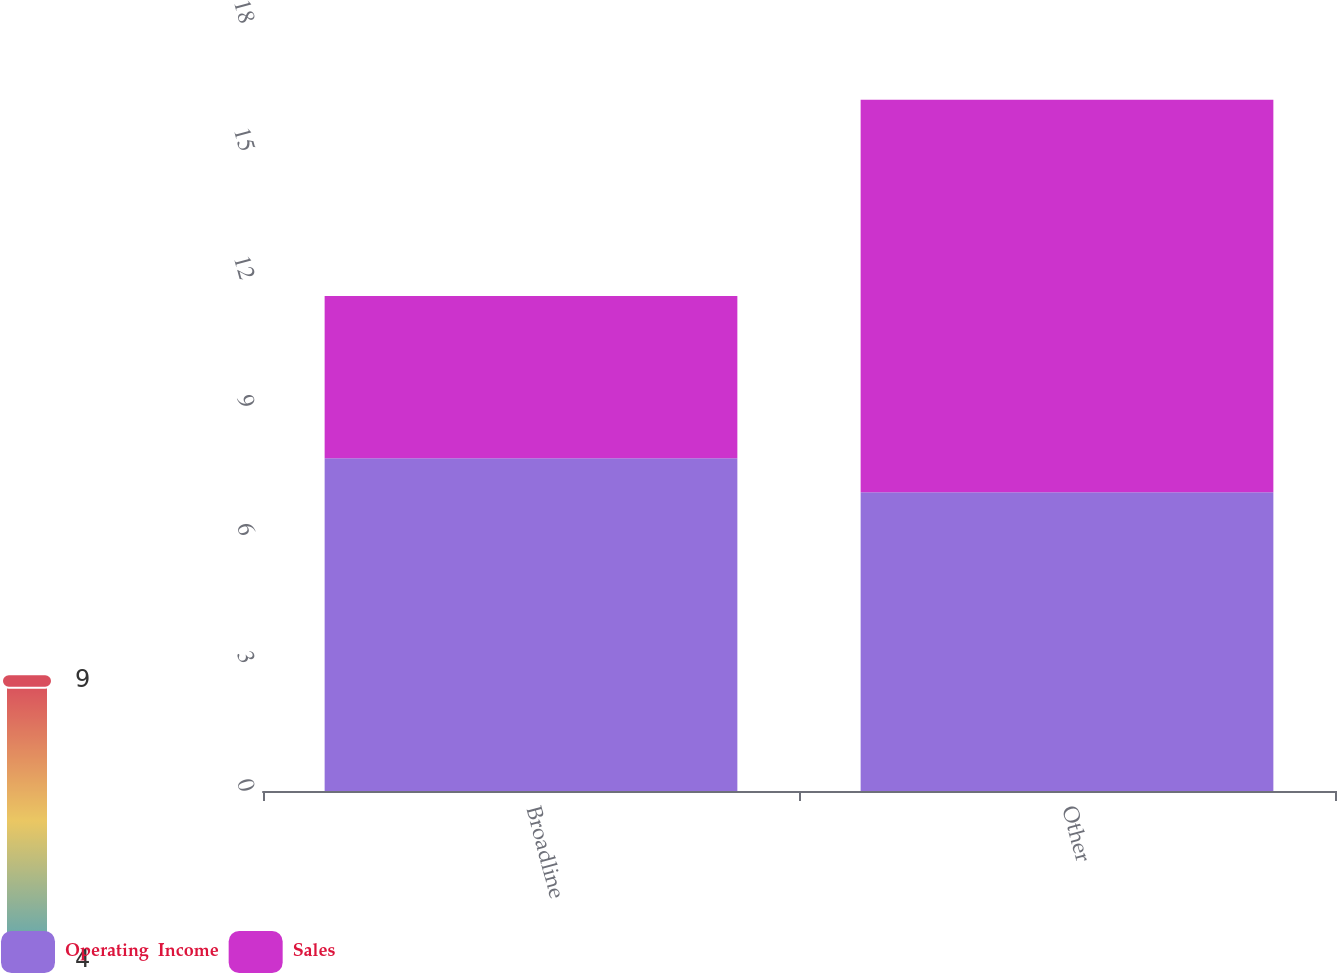Convert chart. <chart><loc_0><loc_0><loc_500><loc_500><stacked_bar_chart><ecel><fcel>Broadline<fcel>Other<nl><fcel>Operating  Income<fcel>7.8<fcel>7<nl><fcel>Sales<fcel>3.8<fcel>9.2<nl></chart> 